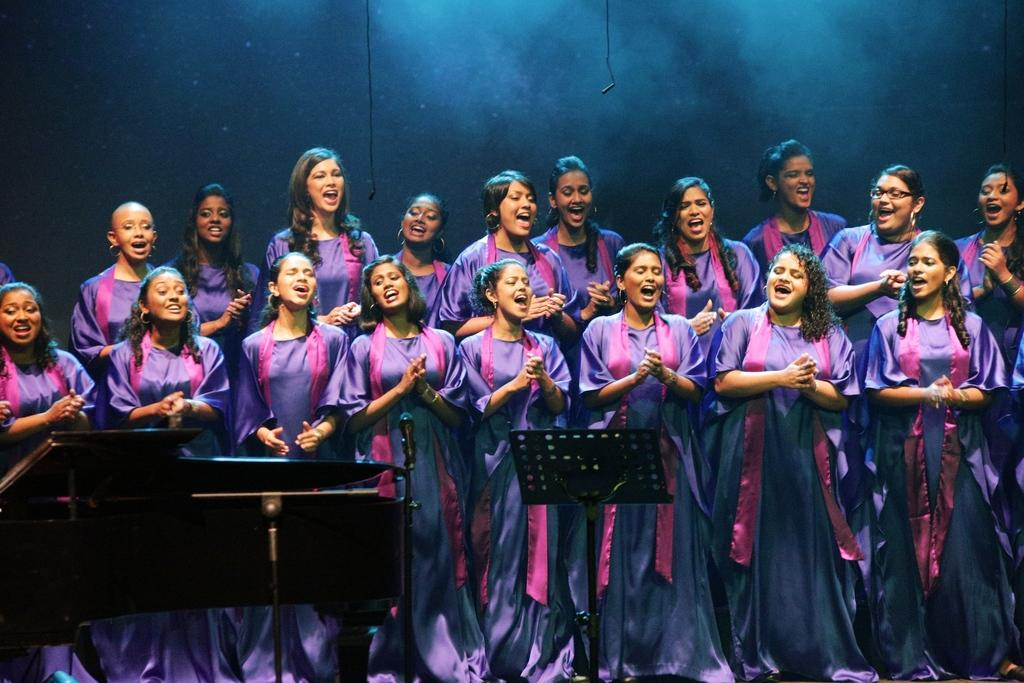What can be seen in the image regarding the people present? There is a group of women in the image. What are the women doing in the image? The women are standing. What are the women wearing in the image? The women are wearing uniforms. What items are present in the image that might be used for communication or performance? There are microphones and musical instruments in the image. Are there any other objects present in the image? Yes, there are other objects in the image. Where is the turkey located in the image? There is no turkey present in the image. What type of harbor can be seen in the background of the image? There is no harbor visible in the image. 